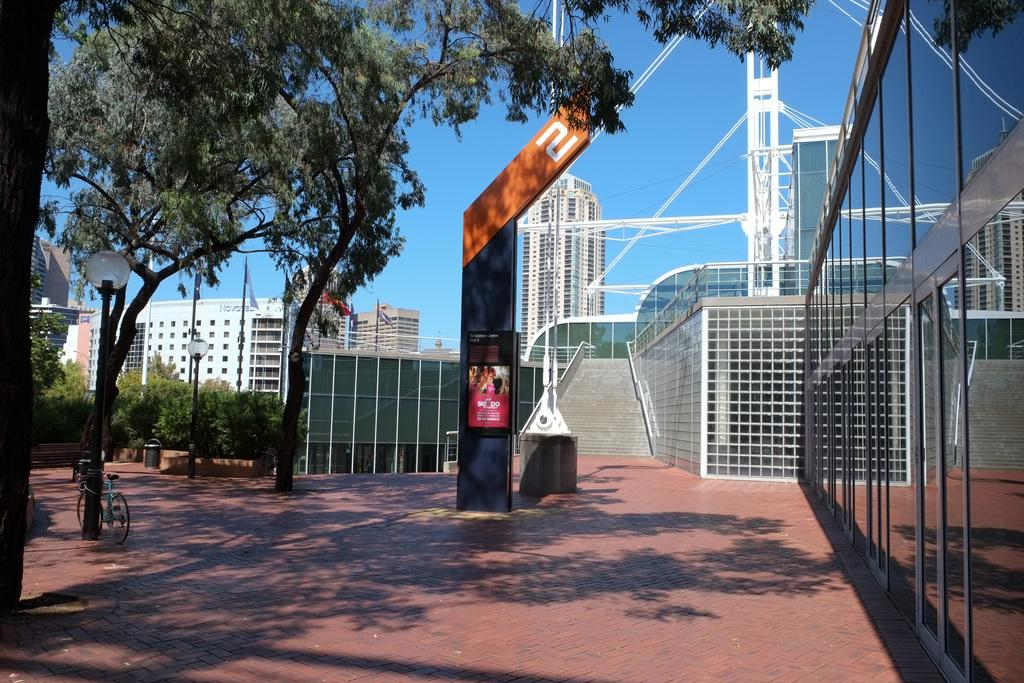What type of vegetation is on the left side of the image? There are trees on the left side of the image. What mode of transportation can be seen at the bottom left of the image? There is a cycle at the bottom left of the image. What structures are visible in the background of the image? There are buildings visible in the background of the image. What architectural feature is present in the middle of the image? There are steps in the middle of the image. What country is the boundary between in the image? There is no boundary present in the image. Who is the friend standing next to the cycle in the image? There is no friend or person visible in the image. 